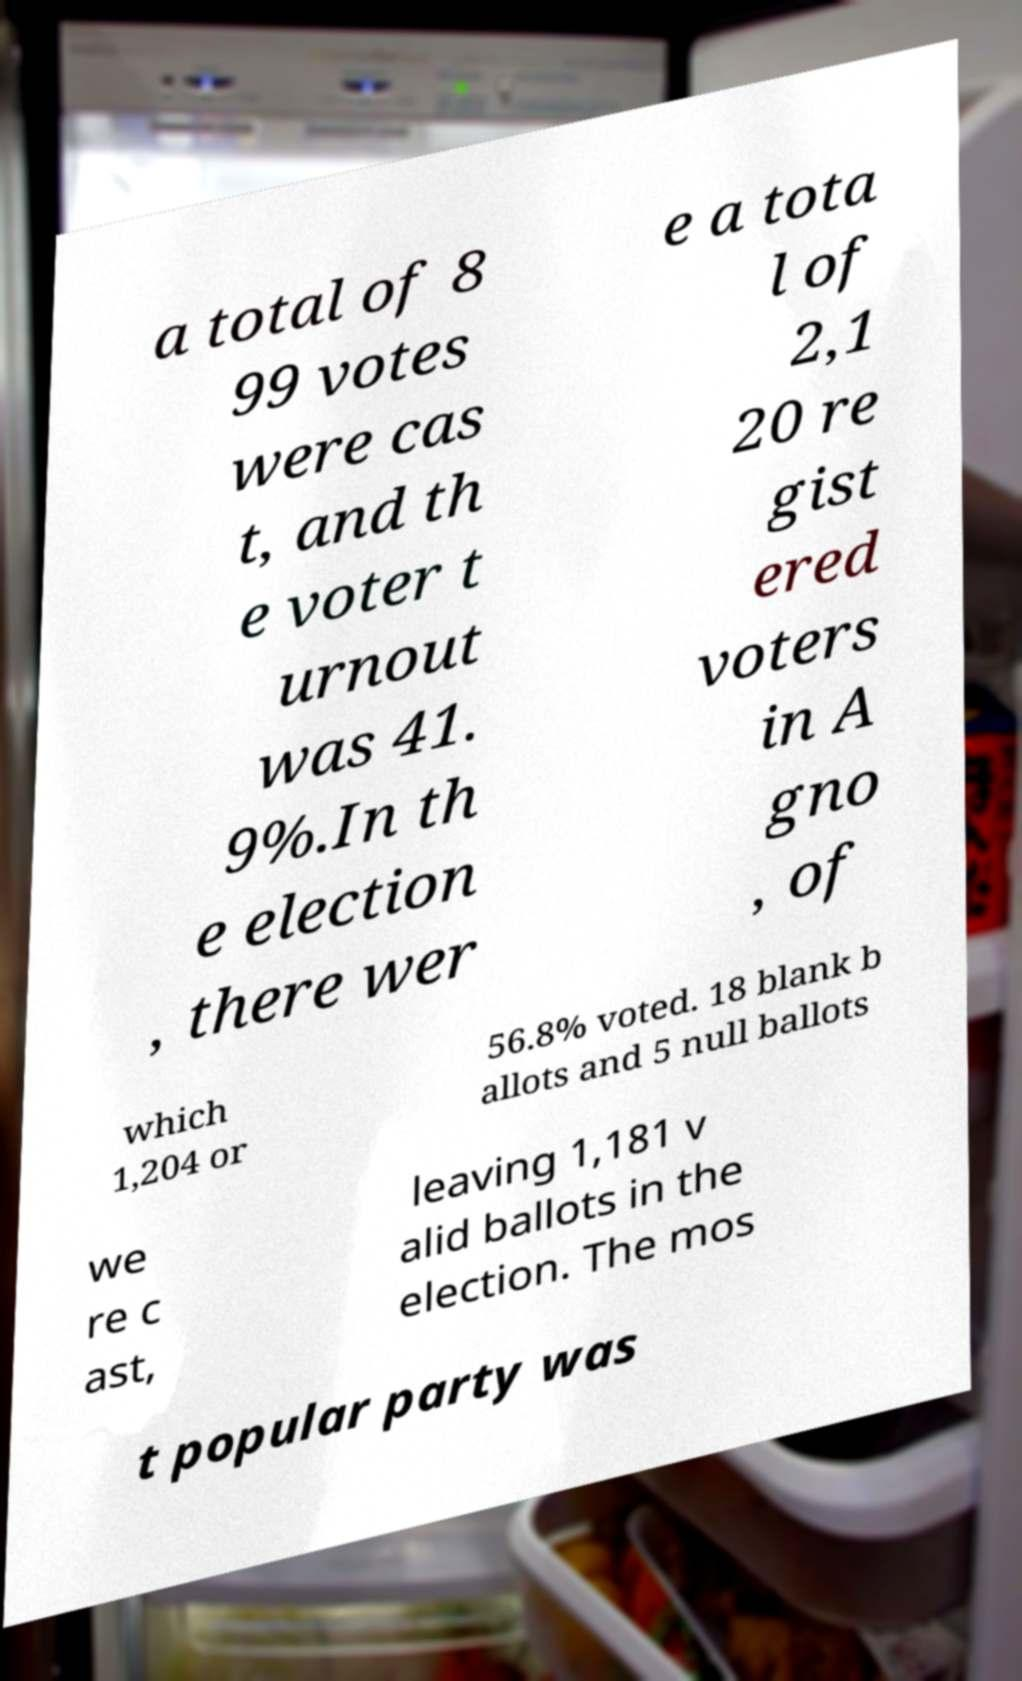Can you accurately transcribe the text from the provided image for me? a total of 8 99 votes were cas t, and th e voter t urnout was 41. 9%.In th e election , there wer e a tota l of 2,1 20 re gist ered voters in A gno , of which 1,204 or 56.8% voted. 18 blank b allots and 5 null ballots we re c ast, leaving 1,181 v alid ballots in the election. The mos t popular party was 